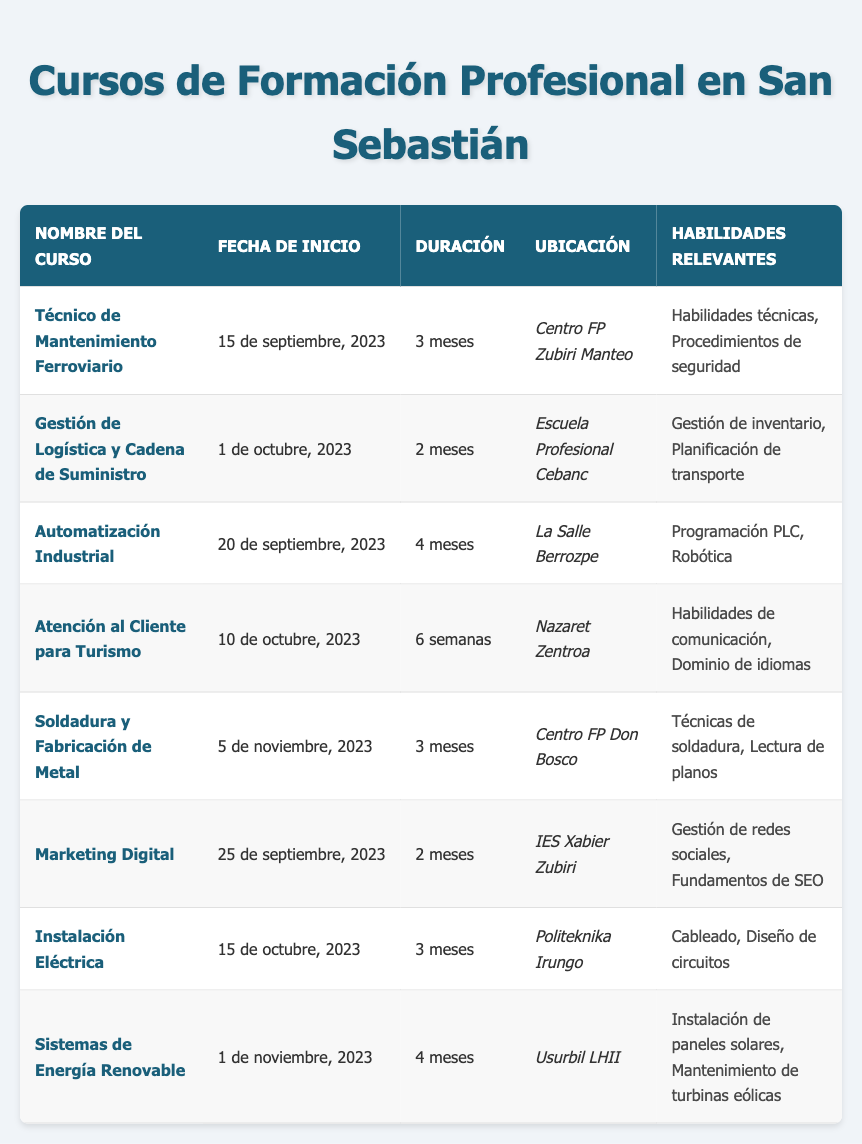What is the duration of the course "Técnico de Mantenimiento Ferroviario"? The duration of the course "Técnico de Mantenimiento Ferroviario" is listed under the "Duración" column. It states that this course lasts for 3 months.
Answer: 3 months Which course starts on October 15, 2023? By looking at the "Fecha de Inicio" column, the course that starts on October 15, 2023, is "Instalación Eléctrica."
Answer: Instalación Eléctrica How many months does the "Sistemas de Energía Renovable" course last? Checking the "Duración" column for "Sistemas de Energía Renovable," it shows the course lasts for 4 months.
Answer: 4 months Is "Welding and Metal Fabrication" offered at Don Bosco VET Center? Looking at the table, the location of the "Welding and Metal Fabrication" course is listed as Don Bosco VET Center, so the statement is true.
Answer: Yes Which course has the most relevant skills related to technology? To determine this, we can review the "Habilidades Relevantes" column for courses emphasizing technical skills. "Técnico de Mantenimiento Ferroviario," "Automatización Industrial," and "Sistemas de Energía Renovable" focus on technical skills such as PLC programming and installation techniques. However, "Automatización Industrial" is listed for 4 months, indicating it has an extensive technical skill set.
Answer: Automatización Industrial What is the average duration of all courses listed? To find the average duration, we add the durations, converting them into months: 3 (Técnico de Mantenimiento Ferroviario) + 2 (Gestión de Logística y Cadena de Suministro) + 4 (Automatización Industrial) + 1.5 (Atención al Cliente para Turismo) + 3 (Soldadura y Fabricación de Metal) + 2 (Marketing Digital) + 3 (Instalación Eléctrica) + 4 (Sistemas de Energía Renovable) = 23.5 months in total. There are 8 courses, so the average is 23.5/8 = 2.94.
Answer: 2.94 months What skills are relevant for the "Atención al Cliente para Turismo" course? Referring to the "Habilidades Relevantes" column for the "Atención al Cliente para Turismo" course, it shows that relevant skills include "Habilidades de comunicación" and "Dominio de idiomas."
Answer: Habilidades de comunicación, Dominio de idiomas Are there any courses starting before October 1, 2023? By checking the "Fecha de Inicio" column, the courses "Técnico de Mantenimiento Ferroviario" (starts September 15, 2023) and "Automatización Industrial" (starts September 20, 2023) begin before October 1, 2023. Thus, the answer is yes.
Answer: Yes Which course has the latest start date? To find the latest start date, we can compare all the start dates. "Soldadura y Fabricación de Metal" starts on November 5, 2023, which is the latest compared to all other courses listed.
Answer: Soldadura y Fabricación de Metal 